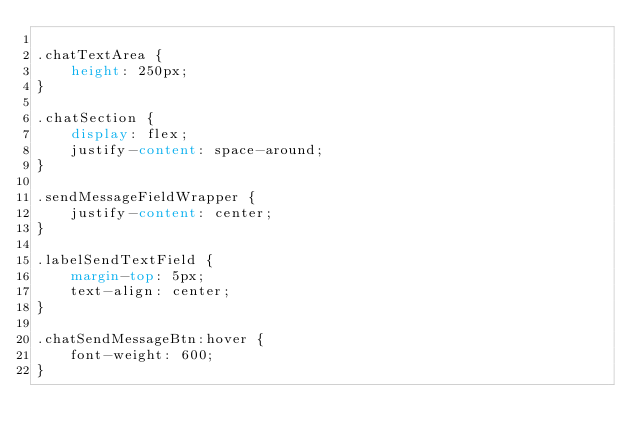<code> <loc_0><loc_0><loc_500><loc_500><_CSS_>
.chatTextArea {
    height: 250px;
}

.chatSection {
    display: flex;
    justify-content: space-around;
}

.sendMessageFieldWrapper {
    justify-content: center;
}

.labelSendTextField {
    margin-top: 5px;
    text-align: center;
}

.chatSendMessageBtn:hover {
    font-weight: 600;
}</code> 